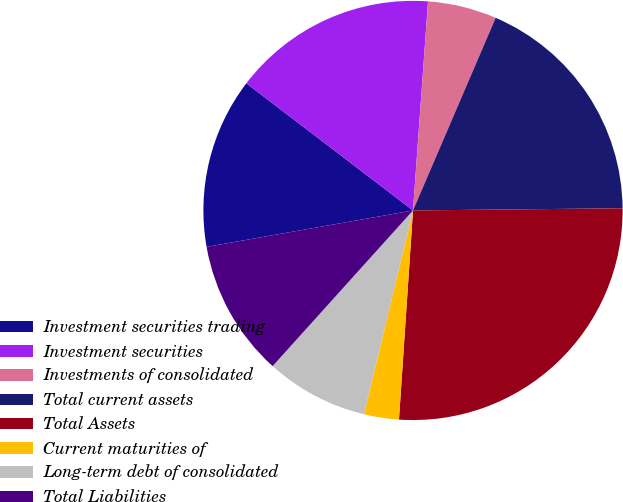Convert chart. <chart><loc_0><loc_0><loc_500><loc_500><pie_chart><fcel>Investment securities trading<fcel>Investment securities<fcel>Investments of consolidated<fcel>Total current assets<fcel>Total Assets<fcel>Current maturities of<fcel>Long-term debt of consolidated<fcel>Total Liabilities<nl><fcel>13.15%<fcel>15.77%<fcel>5.31%<fcel>18.38%<fcel>26.23%<fcel>2.69%<fcel>7.92%<fcel>10.54%<nl></chart> 